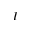Convert formula to latex. <formula><loc_0><loc_0><loc_500><loc_500>I</formula> 